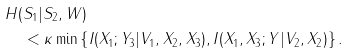<formula> <loc_0><loc_0><loc_500><loc_500>& H ( S _ { 1 } | S _ { 2 } , W ) \\ & \quad < \kappa \min \left \{ I ( X _ { 1 } ; Y _ { 3 } | V _ { 1 } , X _ { 2 } , X _ { 3 } ) , I ( X _ { 1 } , X _ { 3 } ; Y | V _ { 2 } , X _ { 2 } ) \right \} .</formula> 